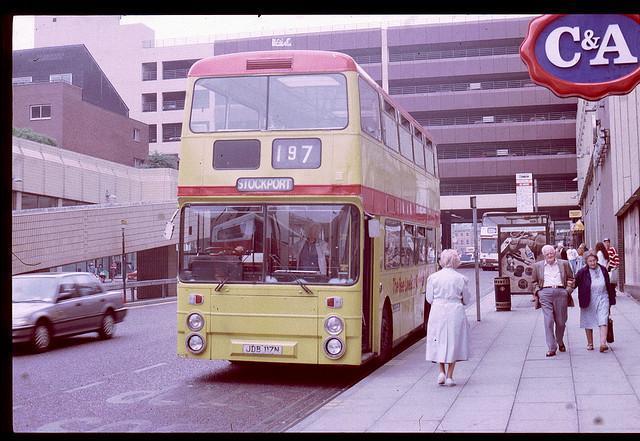How many people are there?
Give a very brief answer. 3. How many motorcycles have an american flag on them?
Give a very brief answer. 0. 